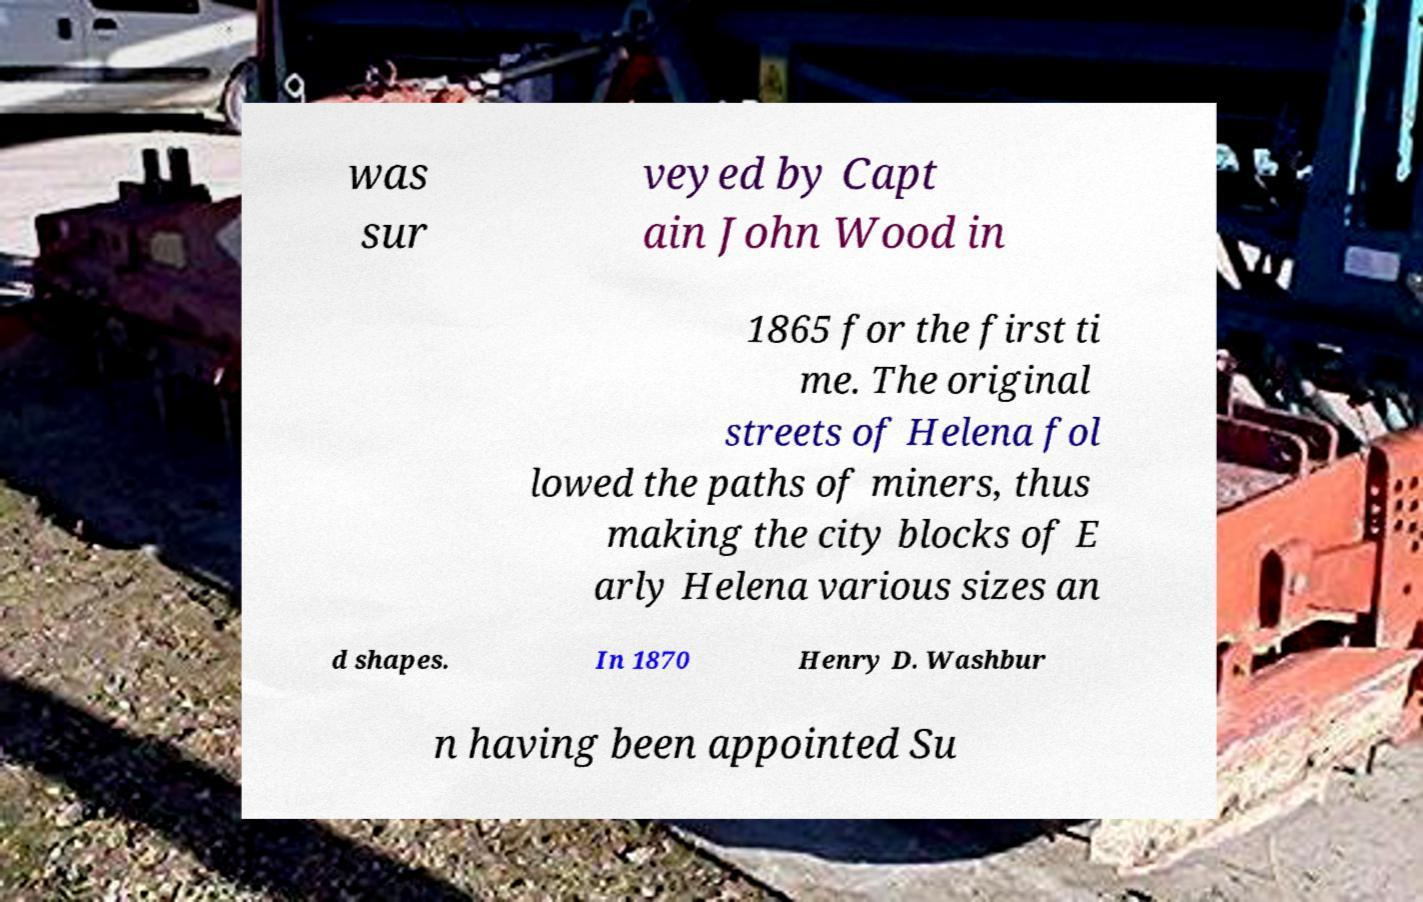Please identify and transcribe the text found in this image. was sur veyed by Capt ain John Wood in 1865 for the first ti me. The original streets of Helena fol lowed the paths of miners, thus making the city blocks of E arly Helena various sizes an d shapes. In 1870 Henry D. Washbur n having been appointed Su 